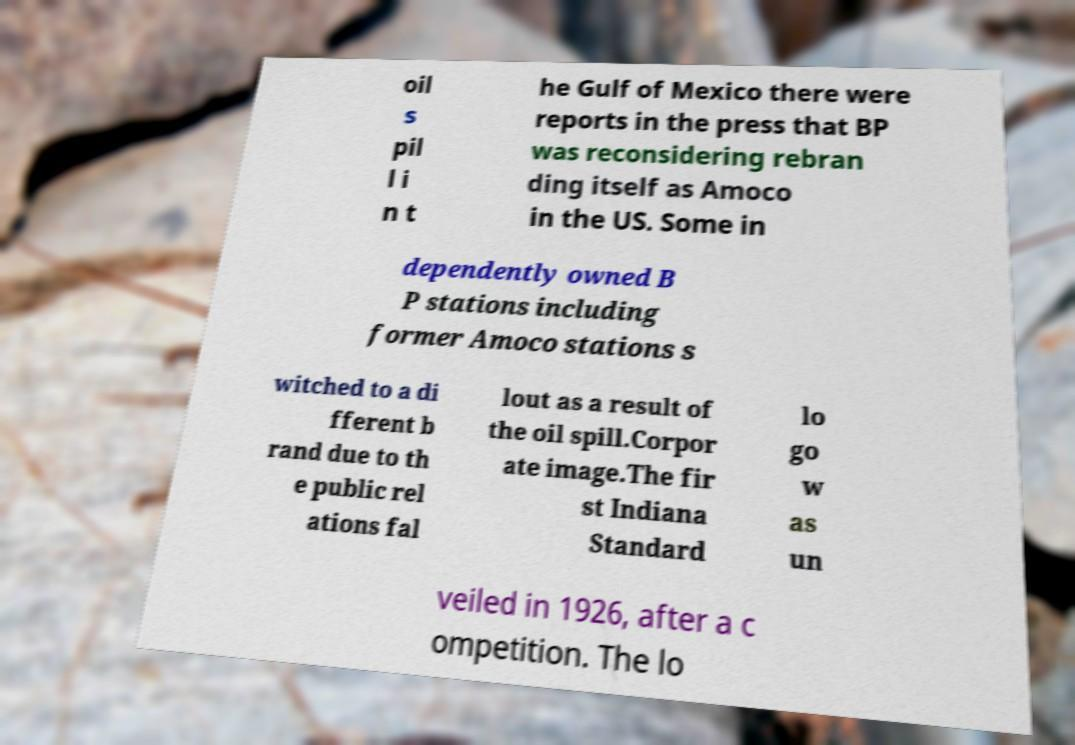Please identify and transcribe the text found in this image. oil s pil l i n t he Gulf of Mexico there were reports in the press that BP was reconsidering rebran ding itself as Amoco in the US. Some in dependently owned B P stations including former Amoco stations s witched to a di fferent b rand due to th e public rel ations fal lout as a result of the oil spill.Corpor ate image.The fir st Indiana Standard lo go w as un veiled in 1926, after a c ompetition. The lo 